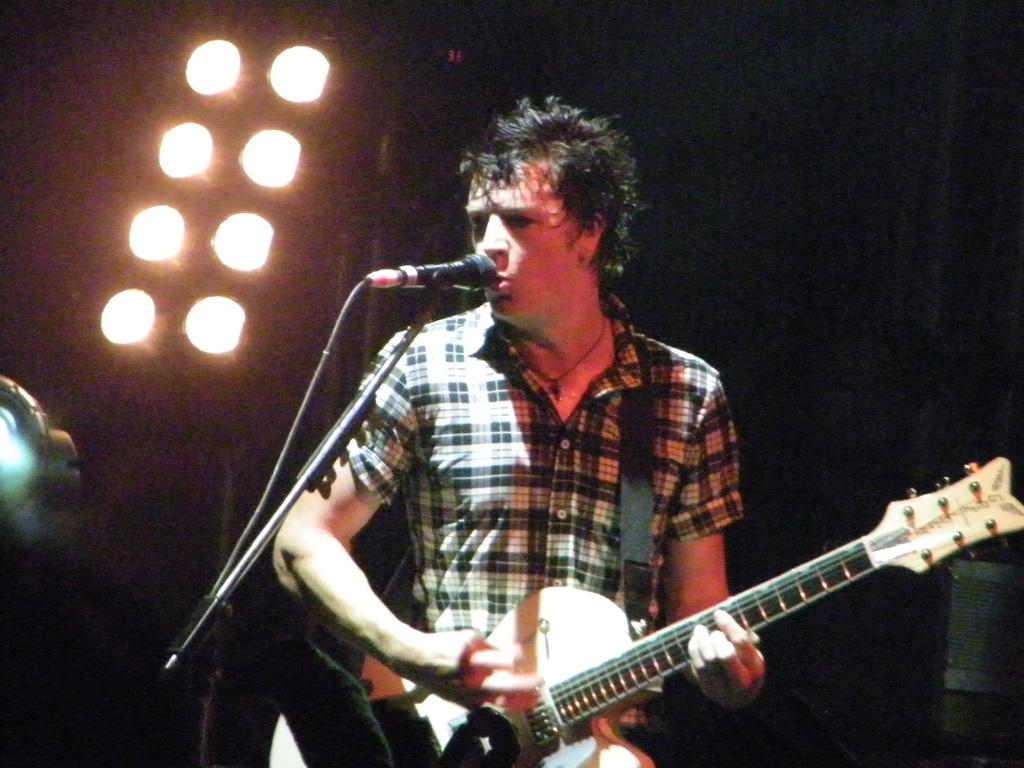What is the person in the image doing? The person is standing, playing a guitar, and singing. What object is beside the person? There is a microphone beside the person. What can be seen in the background of the image? There are lights visible in the background. What type of knowledge can be gained from the person's laugh in the image? There is no mention of a laugh in the image, so no knowledge can be gained from it. 